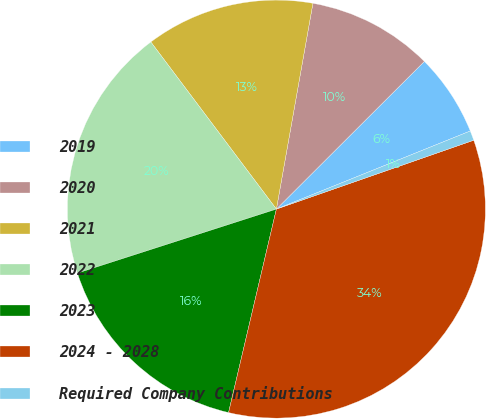Convert chart. <chart><loc_0><loc_0><loc_500><loc_500><pie_chart><fcel>2019<fcel>2020<fcel>2021<fcel>2022<fcel>2023<fcel>2024 - 2028<fcel>Required Company Contributions<nl><fcel>6.39%<fcel>9.72%<fcel>13.05%<fcel>19.7%<fcel>16.37%<fcel>34.02%<fcel>0.75%<nl></chart> 